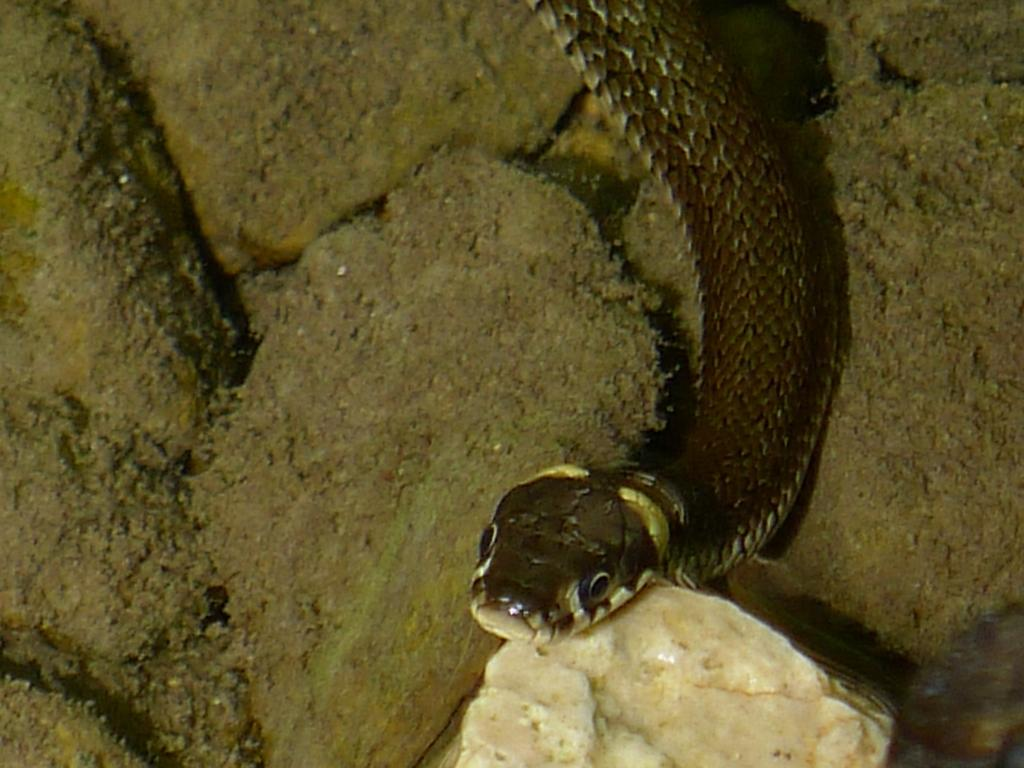What type of animal is present on the right side of the image? There is a snake on stones on the right side of the image. What is the condition of some of the stones in the image? Some stones have moss on them. Where are the other stones located in the image? There are other stones on the left side of the image. What is the condition of these stones? These stones also have moss on them. What type of group is the snake a part of in the image? There is no indication in the image that the snake is part of a group. 